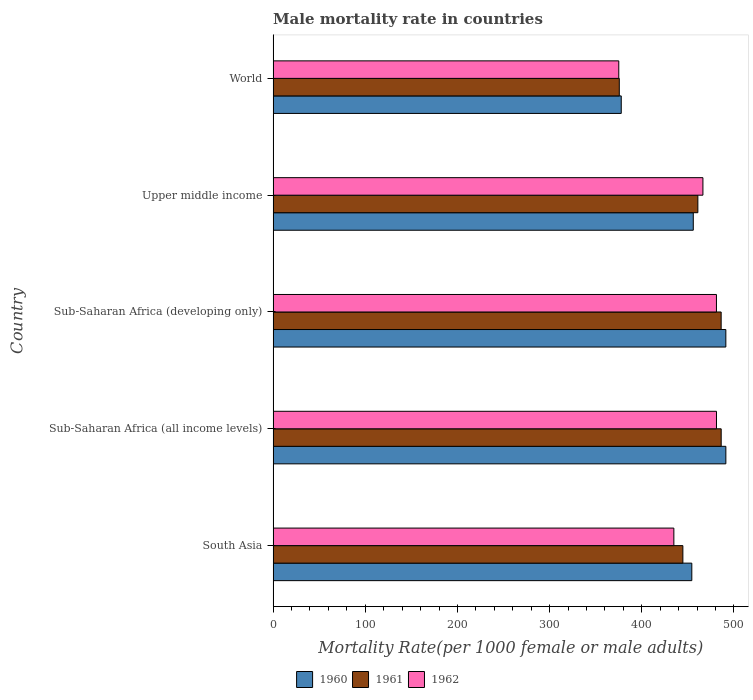Are the number of bars per tick equal to the number of legend labels?
Your answer should be compact. Yes. How many bars are there on the 3rd tick from the top?
Offer a terse response. 3. How many bars are there on the 5th tick from the bottom?
Your answer should be compact. 3. What is the label of the 3rd group of bars from the top?
Your response must be concise. Sub-Saharan Africa (developing only). In how many cases, is the number of bars for a given country not equal to the number of legend labels?
Give a very brief answer. 0. What is the male mortality rate in 1961 in Sub-Saharan Africa (all income levels)?
Give a very brief answer. 486.19. Across all countries, what is the maximum male mortality rate in 1961?
Ensure brevity in your answer.  486.19. Across all countries, what is the minimum male mortality rate in 1961?
Offer a terse response. 375.63. In which country was the male mortality rate in 1962 maximum?
Your response must be concise. Sub-Saharan Africa (all income levels). In which country was the male mortality rate in 1960 minimum?
Make the answer very short. World. What is the total male mortality rate in 1961 in the graph?
Keep it short and to the point. 2253.45. What is the difference between the male mortality rate in 1960 in South Asia and that in Upper middle income?
Keep it short and to the point. -1.6. What is the difference between the male mortality rate in 1961 in Upper middle income and the male mortality rate in 1962 in Sub-Saharan Africa (all income levels)?
Make the answer very short. -20.22. What is the average male mortality rate in 1962 per country?
Provide a short and direct response. 447.69. What is the difference between the male mortality rate in 1960 and male mortality rate in 1961 in World?
Provide a short and direct response. 2.12. In how many countries, is the male mortality rate in 1962 greater than 420 ?
Make the answer very short. 4. What is the ratio of the male mortality rate in 1960 in South Asia to that in World?
Offer a very short reply. 1.2. What is the difference between the highest and the second highest male mortality rate in 1961?
Ensure brevity in your answer.  0.04. What is the difference between the highest and the lowest male mortality rate in 1961?
Provide a short and direct response. 110.55. In how many countries, is the male mortality rate in 1960 greater than the average male mortality rate in 1960 taken over all countries?
Offer a very short reply. 4. Is the sum of the male mortality rate in 1962 in Sub-Saharan Africa (all income levels) and Sub-Saharan Africa (developing only) greater than the maximum male mortality rate in 1960 across all countries?
Give a very brief answer. Yes. What does the 2nd bar from the top in South Asia represents?
Your response must be concise. 1961. Is it the case that in every country, the sum of the male mortality rate in 1962 and male mortality rate in 1960 is greater than the male mortality rate in 1961?
Offer a very short reply. Yes. How many bars are there?
Offer a very short reply. 15. What is the difference between two consecutive major ticks on the X-axis?
Give a very brief answer. 100. Are the values on the major ticks of X-axis written in scientific E-notation?
Provide a succinct answer. No. Does the graph contain any zero values?
Offer a very short reply. No. What is the title of the graph?
Your response must be concise. Male mortality rate in countries. What is the label or title of the X-axis?
Offer a terse response. Mortality Rate(per 1000 female or male adults). What is the Mortality Rate(per 1000 female or male adults) in 1960 in South Asia?
Give a very brief answer. 454.31. What is the Mortality Rate(per 1000 female or male adults) of 1961 in South Asia?
Provide a succinct answer. 444.61. What is the Mortality Rate(per 1000 female or male adults) of 1962 in South Asia?
Keep it short and to the point. 434.84. What is the Mortality Rate(per 1000 female or male adults) of 1960 in Sub-Saharan Africa (all income levels)?
Provide a succinct answer. 491.26. What is the Mortality Rate(per 1000 female or male adults) in 1961 in Sub-Saharan Africa (all income levels)?
Your answer should be very brief. 486.19. What is the Mortality Rate(per 1000 female or male adults) of 1962 in Sub-Saharan Africa (all income levels)?
Make the answer very short. 481.09. What is the Mortality Rate(per 1000 female or male adults) in 1960 in Sub-Saharan Africa (developing only)?
Make the answer very short. 491.24. What is the Mortality Rate(per 1000 female or male adults) of 1961 in Sub-Saharan Africa (developing only)?
Your answer should be very brief. 486.15. What is the Mortality Rate(per 1000 female or male adults) in 1962 in Sub-Saharan Africa (developing only)?
Ensure brevity in your answer.  481.06. What is the Mortality Rate(per 1000 female or male adults) of 1960 in Upper middle income?
Make the answer very short. 455.92. What is the Mortality Rate(per 1000 female or male adults) of 1961 in Upper middle income?
Make the answer very short. 460.87. What is the Mortality Rate(per 1000 female or male adults) in 1962 in Upper middle income?
Provide a short and direct response. 466.38. What is the Mortality Rate(per 1000 female or male adults) in 1960 in World?
Make the answer very short. 377.75. What is the Mortality Rate(per 1000 female or male adults) in 1961 in World?
Your answer should be compact. 375.63. What is the Mortality Rate(per 1000 female or male adults) of 1962 in World?
Make the answer very short. 375.06. Across all countries, what is the maximum Mortality Rate(per 1000 female or male adults) in 1960?
Give a very brief answer. 491.26. Across all countries, what is the maximum Mortality Rate(per 1000 female or male adults) in 1961?
Ensure brevity in your answer.  486.19. Across all countries, what is the maximum Mortality Rate(per 1000 female or male adults) of 1962?
Offer a terse response. 481.09. Across all countries, what is the minimum Mortality Rate(per 1000 female or male adults) of 1960?
Your response must be concise. 377.75. Across all countries, what is the minimum Mortality Rate(per 1000 female or male adults) of 1961?
Make the answer very short. 375.63. Across all countries, what is the minimum Mortality Rate(per 1000 female or male adults) of 1962?
Offer a terse response. 375.06. What is the total Mortality Rate(per 1000 female or male adults) in 1960 in the graph?
Offer a very short reply. 2270.48. What is the total Mortality Rate(per 1000 female or male adults) in 1961 in the graph?
Your answer should be very brief. 2253.45. What is the total Mortality Rate(per 1000 female or male adults) in 1962 in the graph?
Keep it short and to the point. 2238.43. What is the difference between the Mortality Rate(per 1000 female or male adults) of 1960 in South Asia and that in Sub-Saharan Africa (all income levels)?
Keep it short and to the point. -36.94. What is the difference between the Mortality Rate(per 1000 female or male adults) of 1961 in South Asia and that in Sub-Saharan Africa (all income levels)?
Provide a short and direct response. -41.57. What is the difference between the Mortality Rate(per 1000 female or male adults) in 1962 in South Asia and that in Sub-Saharan Africa (all income levels)?
Your response must be concise. -46.25. What is the difference between the Mortality Rate(per 1000 female or male adults) in 1960 in South Asia and that in Sub-Saharan Africa (developing only)?
Offer a very short reply. -36.93. What is the difference between the Mortality Rate(per 1000 female or male adults) of 1961 in South Asia and that in Sub-Saharan Africa (developing only)?
Offer a terse response. -41.54. What is the difference between the Mortality Rate(per 1000 female or male adults) in 1962 in South Asia and that in Sub-Saharan Africa (developing only)?
Your response must be concise. -46.22. What is the difference between the Mortality Rate(per 1000 female or male adults) of 1960 in South Asia and that in Upper middle income?
Offer a very short reply. -1.6. What is the difference between the Mortality Rate(per 1000 female or male adults) in 1961 in South Asia and that in Upper middle income?
Keep it short and to the point. -16.26. What is the difference between the Mortality Rate(per 1000 female or male adults) in 1962 in South Asia and that in Upper middle income?
Keep it short and to the point. -31.54. What is the difference between the Mortality Rate(per 1000 female or male adults) in 1960 in South Asia and that in World?
Give a very brief answer. 76.56. What is the difference between the Mortality Rate(per 1000 female or male adults) of 1961 in South Asia and that in World?
Your response must be concise. 68.98. What is the difference between the Mortality Rate(per 1000 female or male adults) in 1962 in South Asia and that in World?
Your answer should be compact. 59.78. What is the difference between the Mortality Rate(per 1000 female or male adults) in 1960 in Sub-Saharan Africa (all income levels) and that in Sub-Saharan Africa (developing only)?
Make the answer very short. 0.01. What is the difference between the Mortality Rate(per 1000 female or male adults) in 1961 in Sub-Saharan Africa (all income levels) and that in Sub-Saharan Africa (developing only)?
Your response must be concise. 0.04. What is the difference between the Mortality Rate(per 1000 female or male adults) in 1962 in Sub-Saharan Africa (all income levels) and that in Sub-Saharan Africa (developing only)?
Offer a very short reply. 0.04. What is the difference between the Mortality Rate(per 1000 female or male adults) in 1960 in Sub-Saharan Africa (all income levels) and that in Upper middle income?
Keep it short and to the point. 35.34. What is the difference between the Mortality Rate(per 1000 female or male adults) of 1961 in Sub-Saharan Africa (all income levels) and that in Upper middle income?
Offer a very short reply. 25.32. What is the difference between the Mortality Rate(per 1000 female or male adults) in 1962 in Sub-Saharan Africa (all income levels) and that in Upper middle income?
Provide a short and direct response. 14.71. What is the difference between the Mortality Rate(per 1000 female or male adults) of 1960 in Sub-Saharan Africa (all income levels) and that in World?
Ensure brevity in your answer.  113.51. What is the difference between the Mortality Rate(per 1000 female or male adults) in 1961 in Sub-Saharan Africa (all income levels) and that in World?
Your answer should be very brief. 110.55. What is the difference between the Mortality Rate(per 1000 female or male adults) in 1962 in Sub-Saharan Africa (all income levels) and that in World?
Provide a succinct answer. 106.03. What is the difference between the Mortality Rate(per 1000 female or male adults) in 1960 in Sub-Saharan Africa (developing only) and that in Upper middle income?
Your answer should be compact. 35.33. What is the difference between the Mortality Rate(per 1000 female or male adults) in 1961 in Sub-Saharan Africa (developing only) and that in Upper middle income?
Ensure brevity in your answer.  25.28. What is the difference between the Mortality Rate(per 1000 female or male adults) of 1962 in Sub-Saharan Africa (developing only) and that in Upper middle income?
Ensure brevity in your answer.  14.68. What is the difference between the Mortality Rate(per 1000 female or male adults) in 1960 in Sub-Saharan Africa (developing only) and that in World?
Provide a short and direct response. 113.49. What is the difference between the Mortality Rate(per 1000 female or male adults) of 1961 in Sub-Saharan Africa (developing only) and that in World?
Make the answer very short. 110.52. What is the difference between the Mortality Rate(per 1000 female or male adults) in 1962 in Sub-Saharan Africa (developing only) and that in World?
Offer a terse response. 105.99. What is the difference between the Mortality Rate(per 1000 female or male adults) of 1960 in Upper middle income and that in World?
Keep it short and to the point. 78.17. What is the difference between the Mortality Rate(per 1000 female or male adults) in 1961 in Upper middle income and that in World?
Your answer should be compact. 85.24. What is the difference between the Mortality Rate(per 1000 female or male adults) of 1962 in Upper middle income and that in World?
Give a very brief answer. 91.32. What is the difference between the Mortality Rate(per 1000 female or male adults) of 1960 in South Asia and the Mortality Rate(per 1000 female or male adults) of 1961 in Sub-Saharan Africa (all income levels)?
Make the answer very short. -31.87. What is the difference between the Mortality Rate(per 1000 female or male adults) in 1960 in South Asia and the Mortality Rate(per 1000 female or male adults) in 1962 in Sub-Saharan Africa (all income levels)?
Keep it short and to the point. -26.78. What is the difference between the Mortality Rate(per 1000 female or male adults) of 1961 in South Asia and the Mortality Rate(per 1000 female or male adults) of 1962 in Sub-Saharan Africa (all income levels)?
Make the answer very short. -36.48. What is the difference between the Mortality Rate(per 1000 female or male adults) of 1960 in South Asia and the Mortality Rate(per 1000 female or male adults) of 1961 in Sub-Saharan Africa (developing only)?
Offer a very short reply. -31.84. What is the difference between the Mortality Rate(per 1000 female or male adults) of 1960 in South Asia and the Mortality Rate(per 1000 female or male adults) of 1962 in Sub-Saharan Africa (developing only)?
Make the answer very short. -26.74. What is the difference between the Mortality Rate(per 1000 female or male adults) of 1961 in South Asia and the Mortality Rate(per 1000 female or male adults) of 1962 in Sub-Saharan Africa (developing only)?
Your response must be concise. -36.44. What is the difference between the Mortality Rate(per 1000 female or male adults) in 1960 in South Asia and the Mortality Rate(per 1000 female or male adults) in 1961 in Upper middle income?
Your answer should be very brief. -6.56. What is the difference between the Mortality Rate(per 1000 female or male adults) in 1960 in South Asia and the Mortality Rate(per 1000 female or male adults) in 1962 in Upper middle income?
Your response must be concise. -12.06. What is the difference between the Mortality Rate(per 1000 female or male adults) of 1961 in South Asia and the Mortality Rate(per 1000 female or male adults) of 1962 in Upper middle income?
Offer a terse response. -21.77. What is the difference between the Mortality Rate(per 1000 female or male adults) of 1960 in South Asia and the Mortality Rate(per 1000 female or male adults) of 1961 in World?
Offer a very short reply. 78.68. What is the difference between the Mortality Rate(per 1000 female or male adults) of 1960 in South Asia and the Mortality Rate(per 1000 female or male adults) of 1962 in World?
Make the answer very short. 79.25. What is the difference between the Mortality Rate(per 1000 female or male adults) in 1961 in South Asia and the Mortality Rate(per 1000 female or male adults) in 1962 in World?
Your answer should be compact. 69.55. What is the difference between the Mortality Rate(per 1000 female or male adults) in 1960 in Sub-Saharan Africa (all income levels) and the Mortality Rate(per 1000 female or male adults) in 1961 in Sub-Saharan Africa (developing only)?
Give a very brief answer. 5.11. What is the difference between the Mortality Rate(per 1000 female or male adults) in 1960 in Sub-Saharan Africa (all income levels) and the Mortality Rate(per 1000 female or male adults) in 1962 in Sub-Saharan Africa (developing only)?
Offer a very short reply. 10.2. What is the difference between the Mortality Rate(per 1000 female or male adults) in 1961 in Sub-Saharan Africa (all income levels) and the Mortality Rate(per 1000 female or male adults) in 1962 in Sub-Saharan Africa (developing only)?
Give a very brief answer. 5.13. What is the difference between the Mortality Rate(per 1000 female or male adults) in 1960 in Sub-Saharan Africa (all income levels) and the Mortality Rate(per 1000 female or male adults) in 1961 in Upper middle income?
Ensure brevity in your answer.  30.39. What is the difference between the Mortality Rate(per 1000 female or male adults) in 1960 in Sub-Saharan Africa (all income levels) and the Mortality Rate(per 1000 female or male adults) in 1962 in Upper middle income?
Ensure brevity in your answer.  24.88. What is the difference between the Mortality Rate(per 1000 female or male adults) in 1961 in Sub-Saharan Africa (all income levels) and the Mortality Rate(per 1000 female or male adults) in 1962 in Upper middle income?
Your answer should be very brief. 19.81. What is the difference between the Mortality Rate(per 1000 female or male adults) of 1960 in Sub-Saharan Africa (all income levels) and the Mortality Rate(per 1000 female or male adults) of 1961 in World?
Make the answer very short. 115.62. What is the difference between the Mortality Rate(per 1000 female or male adults) of 1960 in Sub-Saharan Africa (all income levels) and the Mortality Rate(per 1000 female or male adults) of 1962 in World?
Provide a short and direct response. 116.19. What is the difference between the Mortality Rate(per 1000 female or male adults) of 1961 in Sub-Saharan Africa (all income levels) and the Mortality Rate(per 1000 female or male adults) of 1962 in World?
Your answer should be very brief. 111.12. What is the difference between the Mortality Rate(per 1000 female or male adults) in 1960 in Sub-Saharan Africa (developing only) and the Mortality Rate(per 1000 female or male adults) in 1961 in Upper middle income?
Ensure brevity in your answer.  30.37. What is the difference between the Mortality Rate(per 1000 female or male adults) of 1960 in Sub-Saharan Africa (developing only) and the Mortality Rate(per 1000 female or male adults) of 1962 in Upper middle income?
Offer a very short reply. 24.87. What is the difference between the Mortality Rate(per 1000 female or male adults) in 1961 in Sub-Saharan Africa (developing only) and the Mortality Rate(per 1000 female or male adults) in 1962 in Upper middle income?
Provide a short and direct response. 19.77. What is the difference between the Mortality Rate(per 1000 female or male adults) of 1960 in Sub-Saharan Africa (developing only) and the Mortality Rate(per 1000 female or male adults) of 1961 in World?
Give a very brief answer. 115.61. What is the difference between the Mortality Rate(per 1000 female or male adults) of 1960 in Sub-Saharan Africa (developing only) and the Mortality Rate(per 1000 female or male adults) of 1962 in World?
Your answer should be very brief. 116.18. What is the difference between the Mortality Rate(per 1000 female or male adults) in 1961 in Sub-Saharan Africa (developing only) and the Mortality Rate(per 1000 female or male adults) in 1962 in World?
Offer a very short reply. 111.09. What is the difference between the Mortality Rate(per 1000 female or male adults) in 1960 in Upper middle income and the Mortality Rate(per 1000 female or male adults) in 1961 in World?
Provide a succinct answer. 80.28. What is the difference between the Mortality Rate(per 1000 female or male adults) in 1960 in Upper middle income and the Mortality Rate(per 1000 female or male adults) in 1962 in World?
Provide a succinct answer. 80.85. What is the difference between the Mortality Rate(per 1000 female or male adults) in 1961 in Upper middle income and the Mortality Rate(per 1000 female or male adults) in 1962 in World?
Offer a very short reply. 85.81. What is the average Mortality Rate(per 1000 female or male adults) of 1960 per country?
Your answer should be very brief. 454.1. What is the average Mortality Rate(per 1000 female or male adults) in 1961 per country?
Keep it short and to the point. 450.69. What is the average Mortality Rate(per 1000 female or male adults) of 1962 per country?
Provide a succinct answer. 447.69. What is the difference between the Mortality Rate(per 1000 female or male adults) of 1960 and Mortality Rate(per 1000 female or male adults) of 1961 in South Asia?
Offer a terse response. 9.7. What is the difference between the Mortality Rate(per 1000 female or male adults) in 1960 and Mortality Rate(per 1000 female or male adults) in 1962 in South Asia?
Your response must be concise. 19.48. What is the difference between the Mortality Rate(per 1000 female or male adults) in 1961 and Mortality Rate(per 1000 female or male adults) in 1962 in South Asia?
Provide a short and direct response. 9.77. What is the difference between the Mortality Rate(per 1000 female or male adults) in 1960 and Mortality Rate(per 1000 female or male adults) in 1961 in Sub-Saharan Africa (all income levels)?
Provide a succinct answer. 5.07. What is the difference between the Mortality Rate(per 1000 female or male adults) of 1960 and Mortality Rate(per 1000 female or male adults) of 1962 in Sub-Saharan Africa (all income levels)?
Give a very brief answer. 10.16. What is the difference between the Mortality Rate(per 1000 female or male adults) of 1961 and Mortality Rate(per 1000 female or male adults) of 1962 in Sub-Saharan Africa (all income levels)?
Your answer should be very brief. 5.09. What is the difference between the Mortality Rate(per 1000 female or male adults) of 1960 and Mortality Rate(per 1000 female or male adults) of 1961 in Sub-Saharan Africa (developing only)?
Your answer should be compact. 5.09. What is the difference between the Mortality Rate(per 1000 female or male adults) of 1960 and Mortality Rate(per 1000 female or male adults) of 1962 in Sub-Saharan Africa (developing only)?
Make the answer very short. 10.19. What is the difference between the Mortality Rate(per 1000 female or male adults) of 1961 and Mortality Rate(per 1000 female or male adults) of 1962 in Sub-Saharan Africa (developing only)?
Give a very brief answer. 5.1. What is the difference between the Mortality Rate(per 1000 female or male adults) of 1960 and Mortality Rate(per 1000 female or male adults) of 1961 in Upper middle income?
Your answer should be compact. -4.95. What is the difference between the Mortality Rate(per 1000 female or male adults) in 1960 and Mortality Rate(per 1000 female or male adults) in 1962 in Upper middle income?
Your answer should be very brief. -10.46. What is the difference between the Mortality Rate(per 1000 female or male adults) of 1961 and Mortality Rate(per 1000 female or male adults) of 1962 in Upper middle income?
Offer a very short reply. -5.51. What is the difference between the Mortality Rate(per 1000 female or male adults) of 1960 and Mortality Rate(per 1000 female or male adults) of 1961 in World?
Provide a succinct answer. 2.12. What is the difference between the Mortality Rate(per 1000 female or male adults) in 1960 and Mortality Rate(per 1000 female or male adults) in 1962 in World?
Provide a short and direct response. 2.69. What is the difference between the Mortality Rate(per 1000 female or male adults) of 1961 and Mortality Rate(per 1000 female or male adults) of 1962 in World?
Provide a short and direct response. 0.57. What is the ratio of the Mortality Rate(per 1000 female or male adults) in 1960 in South Asia to that in Sub-Saharan Africa (all income levels)?
Your response must be concise. 0.92. What is the ratio of the Mortality Rate(per 1000 female or male adults) in 1961 in South Asia to that in Sub-Saharan Africa (all income levels)?
Your answer should be very brief. 0.91. What is the ratio of the Mortality Rate(per 1000 female or male adults) in 1962 in South Asia to that in Sub-Saharan Africa (all income levels)?
Your answer should be compact. 0.9. What is the ratio of the Mortality Rate(per 1000 female or male adults) of 1960 in South Asia to that in Sub-Saharan Africa (developing only)?
Offer a very short reply. 0.92. What is the ratio of the Mortality Rate(per 1000 female or male adults) of 1961 in South Asia to that in Sub-Saharan Africa (developing only)?
Make the answer very short. 0.91. What is the ratio of the Mortality Rate(per 1000 female or male adults) in 1962 in South Asia to that in Sub-Saharan Africa (developing only)?
Provide a short and direct response. 0.9. What is the ratio of the Mortality Rate(per 1000 female or male adults) in 1961 in South Asia to that in Upper middle income?
Your answer should be very brief. 0.96. What is the ratio of the Mortality Rate(per 1000 female or male adults) in 1962 in South Asia to that in Upper middle income?
Ensure brevity in your answer.  0.93. What is the ratio of the Mortality Rate(per 1000 female or male adults) in 1960 in South Asia to that in World?
Your answer should be compact. 1.2. What is the ratio of the Mortality Rate(per 1000 female or male adults) of 1961 in South Asia to that in World?
Your answer should be very brief. 1.18. What is the ratio of the Mortality Rate(per 1000 female or male adults) in 1962 in South Asia to that in World?
Your response must be concise. 1.16. What is the ratio of the Mortality Rate(per 1000 female or male adults) of 1960 in Sub-Saharan Africa (all income levels) to that in Sub-Saharan Africa (developing only)?
Make the answer very short. 1. What is the ratio of the Mortality Rate(per 1000 female or male adults) in 1961 in Sub-Saharan Africa (all income levels) to that in Sub-Saharan Africa (developing only)?
Provide a succinct answer. 1. What is the ratio of the Mortality Rate(per 1000 female or male adults) in 1960 in Sub-Saharan Africa (all income levels) to that in Upper middle income?
Keep it short and to the point. 1.08. What is the ratio of the Mortality Rate(per 1000 female or male adults) of 1961 in Sub-Saharan Africa (all income levels) to that in Upper middle income?
Your answer should be very brief. 1.05. What is the ratio of the Mortality Rate(per 1000 female or male adults) of 1962 in Sub-Saharan Africa (all income levels) to that in Upper middle income?
Your response must be concise. 1.03. What is the ratio of the Mortality Rate(per 1000 female or male adults) in 1960 in Sub-Saharan Africa (all income levels) to that in World?
Your response must be concise. 1.3. What is the ratio of the Mortality Rate(per 1000 female or male adults) in 1961 in Sub-Saharan Africa (all income levels) to that in World?
Keep it short and to the point. 1.29. What is the ratio of the Mortality Rate(per 1000 female or male adults) of 1962 in Sub-Saharan Africa (all income levels) to that in World?
Keep it short and to the point. 1.28. What is the ratio of the Mortality Rate(per 1000 female or male adults) in 1960 in Sub-Saharan Africa (developing only) to that in Upper middle income?
Provide a short and direct response. 1.08. What is the ratio of the Mortality Rate(per 1000 female or male adults) of 1961 in Sub-Saharan Africa (developing only) to that in Upper middle income?
Ensure brevity in your answer.  1.05. What is the ratio of the Mortality Rate(per 1000 female or male adults) in 1962 in Sub-Saharan Africa (developing only) to that in Upper middle income?
Keep it short and to the point. 1.03. What is the ratio of the Mortality Rate(per 1000 female or male adults) of 1960 in Sub-Saharan Africa (developing only) to that in World?
Keep it short and to the point. 1.3. What is the ratio of the Mortality Rate(per 1000 female or male adults) in 1961 in Sub-Saharan Africa (developing only) to that in World?
Offer a very short reply. 1.29. What is the ratio of the Mortality Rate(per 1000 female or male adults) in 1962 in Sub-Saharan Africa (developing only) to that in World?
Your answer should be very brief. 1.28. What is the ratio of the Mortality Rate(per 1000 female or male adults) of 1960 in Upper middle income to that in World?
Your answer should be very brief. 1.21. What is the ratio of the Mortality Rate(per 1000 female or male adults) in 1961 in Upper middle income to that in World?
Provide a succinct answer. 1.23. What is the ratio of the Mortality Rate(per 1000 female or male adults) in 1962 in Upper middle income to that in World?
Provide a succinct answer. 1.24. What is the difference between the highest and the second highest Mortality Rate(per 1000 female or male adults) of 1960?
Keep it short and to the point. 0.01. What is the difference between the highest and the second highest Mortality Rate(per 1000 female or male adults) in 1961?
Your answer should be very brief. 0.04. What is the difference between the highest and the second highest Mortality Rate(per 1000 female or male adults) in 1962?
Provide a short and direct response. 0.04. What is the difference between the highest and the lowest Mortality Rate(per 1000 female or male adults) of 1960?
Offer a terse response. 113.51. What is the difference between the highest and the lowest Mortality Rate(per 1000 female or male adults) of 1961?
Ensure brevity in your answer.  110.55. What is the difference between the highest and the lowest Mortality Rate(per 1000 female or male adults) in 1962?
Provide a succinct answer. 106.03. 